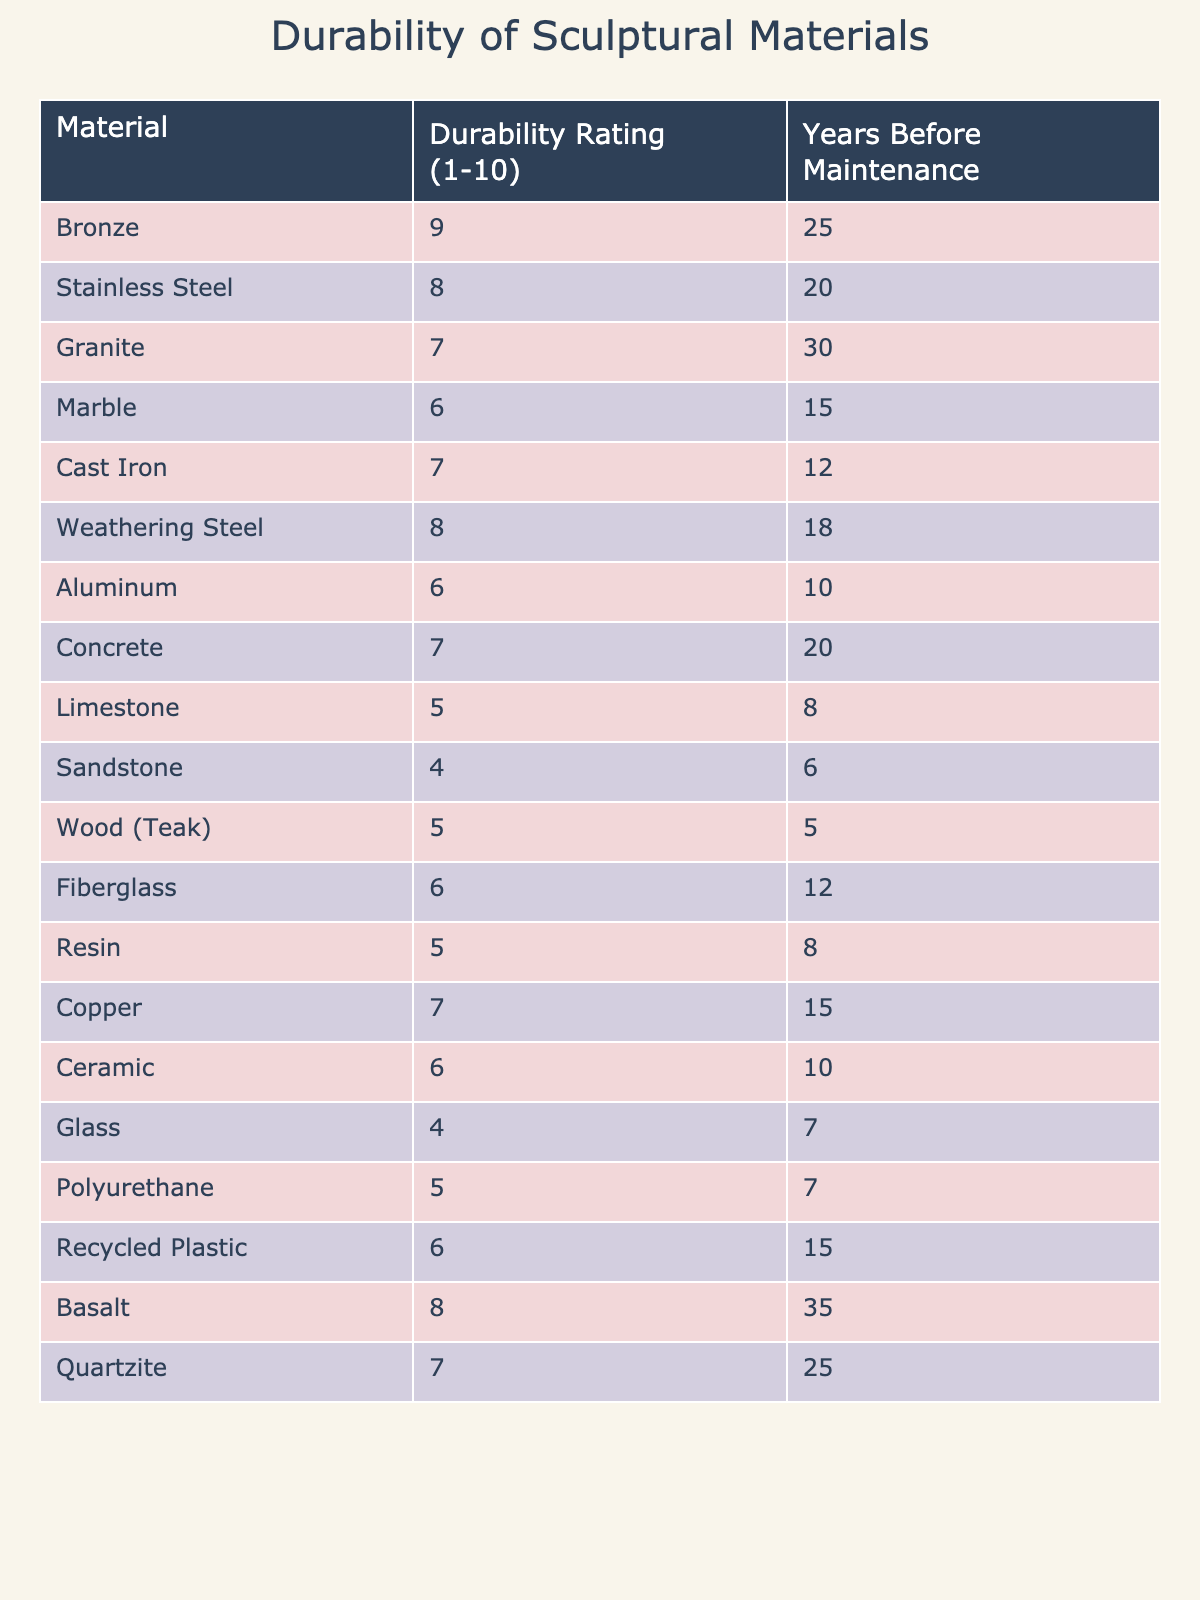What material has the highest durability rating? Looking at the durability ratings in the table, bronze has the highest rating of 9.
Answer: Bronze How many years does limestone last before maintenance is needed? The table shows that limestone requires maintenance after 8 years.
Answer: 8 years Which material requires maintenance the quickest? By comparing the "Years Before Maintenance" column, wood (teak) requires maintenance after just 5 years, which is the shortest time.
Answer: Wood (Teak) Which materials have a durability rating of 6? The table lists marble, aluminum, fiberglass, ceramic, glass, and polyurethane as materials with a durability rating of 6.
Answer: Marble, Aluminum, Fiberglass, Ceramic, Glass, Polyurethane What is the average durability rating for all listed materials? The total durability ratings add up to 104 across 15 materials, so the average is 104/15 = 6.93, which can be rounded to 7.
Answer: 7 If you want a material that lasts at least 20 years before maintenance, which options do you have? The relevant materials are granite (30 years), concrete (20 years), and basalt (35 years).
Answer: Granite, Concrete, Basalt True or False: Copper has a higher durability rating than stainless steel. The table indicates that copper has a durability rating of 7, while stainless steel has a rating of 8, so the statement is false.
Answer: False Which materials can last for at least 15 years before maintenance? The materials include bronze (25 years), granite (30 years), stainless steel (20 years), weathering steel (18 years), concrete (20 years), copper (15 years), quartzite (25 years), and basalt (35 years).
Answer: Bronze, Granite, Stainless Steel, Weathering Steel, Concrete, Copper, Quartzite, Basalt What is the difference in durability ratings between sandstone and granite? Sandstone has a durability rating of 4 and granite has a rating of 7. The difference is 7 - 4 = 3.
Answer: 3 Which material has the longest lifespan before maintenance? The table shows that basalt lasts the longest with 35 years before maintenance is needed.
Answer: Basalt 